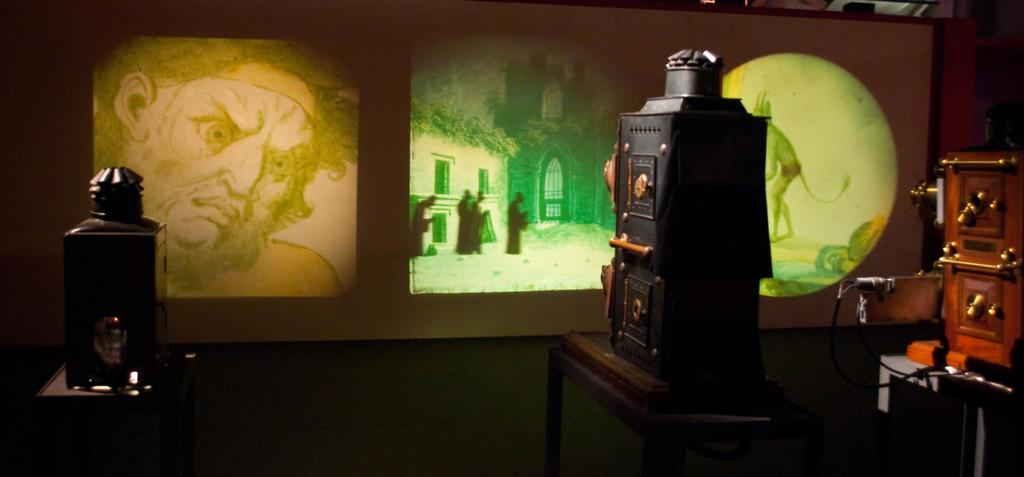What objects can be seen on the table in the image? There are three instruments on the table. What can be seen in the background of the image? There is a group of pictures on the wall in the background. How does the society depicted in the images on the wall answer the questions posed by the instruments? There is no society depicted in the images on the wall, nor are there any questions posed by the instruments. The image only shows three instruments on a table and a group of pictures on the wall in the background. 